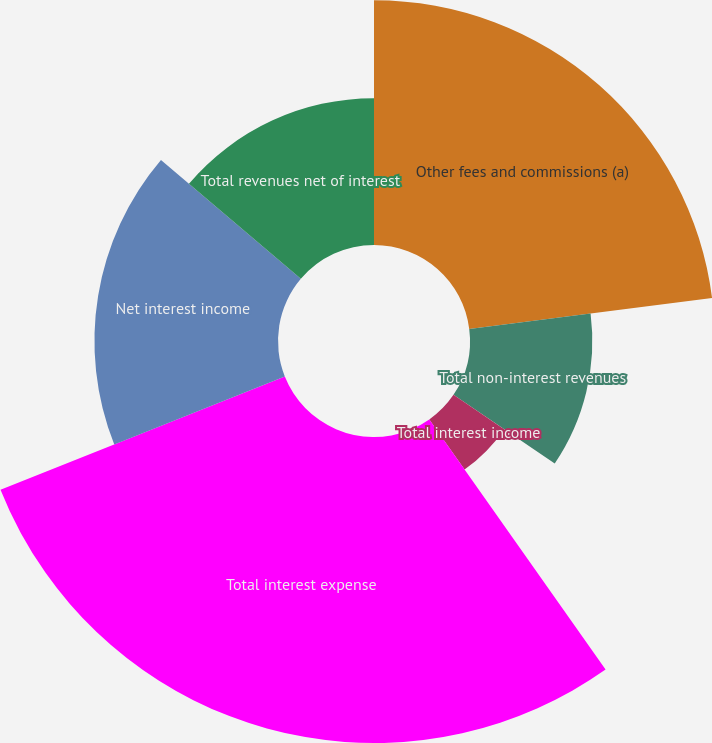Convert chart to OTSL. <chart><loc_0><loc_0><loc_500><loc_500><pie_chart><fcel>Other fees and commissions (a)<fcel>Total non-interest revenues<fcel>Total interest income<fcel>Total interest expense<fcel>Net interest income<fcel>Total revenues net of interest<nl><fcel>22.99%<fcel>11.49%<fcel>5.75%<fcel>28.74%<fcel>17.24%<fcel>13.79%<nl></chart> 